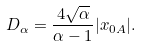Convert formula to latex. <formula><loc_0><loc_0><loc_500><loc_500>D _ { \alpha } = \frac { 4 \sqrt { \alpha } } { \alpha - 1 } | x _ { 0 A } | .</formula> 